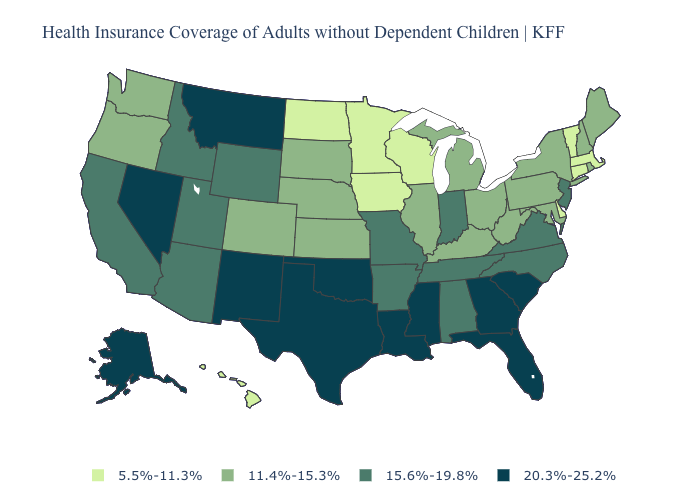Among the states that border Indiana , which have the lowest value?
Give a very brief answer. Illinois, Kentucky, Michigan, Ohio. What is the value of Ohio?
Concise answer only. 11.4%-15.3%. Does Virginia have a lower value than Nebraska?
Quick response, please. No. What is the value of Idaho?
Be succinct. 15.6%-19.8%. Name the states that have a value in the range 11.4%-15.3%?
Concise answer only. Colorado, Illinois, Kansas, Kentucky, Maine, Maryland, Michigan, Nebraska, New Hampshire, New York, Ohio, Oregon, Pennsylvania, Rhode Island, South Dakota, Washington, West Virginia. Which states have the lowest value in the West?
Concise answer only. Hawaii. Name the states that have a value in the range 15.6%-19.8%?
Quick response, please. Alabama, Arizona, Arkansas, California, Idaho, Indiana, Missouri, New Jersey, North Carolina, Tennessee, Utah, Virginia, Wyoming. What is the value of Nebraska?
Quick response, please. 11.4%-15.3%. What is the value of Tennessee?
Quick response, please. 15.6%-19.8%. Among the states that border Utah , does Colorado have the lowest value?
Keep it brief. Yes. What is the highest value in the MidWest ?
Short answer required. 15.6%-19.8%. Among the states that border Wisconsin , which have the highest value?
Give a very brief answer. Illinois, Michigan. What is the lowest value in the Northeast?
Give a very brief answer. 5.5%-11.3%. Does Oregon have a higher value than Delaware?
Keep it brief. Yes. Name the states that have a value in the range 11.4%-15.3%?
Answer briefly. Colorado, Illinois, Kansas, Kentucky, Maine, Maryland, Michigan, Nebraska, New Hampshire, New York, Ohio, Oregon, Pennsylvania, Rhode Island, South Dakota, Washington, West Virginia. 